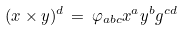Convert formula to latex. <formula><loc_0><loc_0><loc_500><loc_500>( x \times y ) ^ { d } \, = \, \varphi _ { a b c } x ^ { a } y ^ { b } g ^ { c d }</formula> 